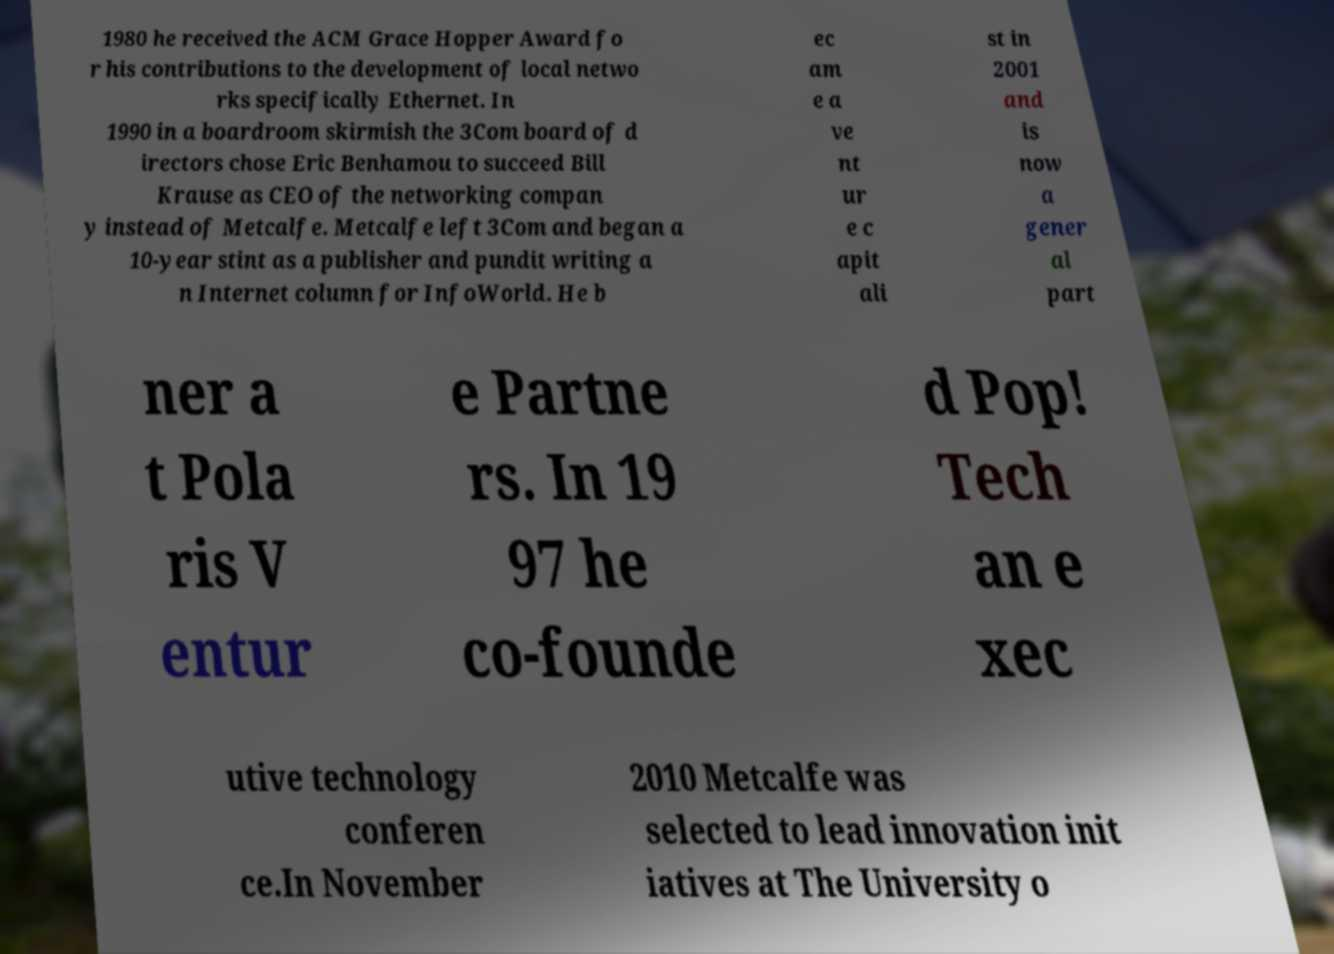What messages or text are displayed in this image? I need them in a readable, typed format. 1980 he received the ACM Grace Hopper Award fo r his contributions to the development of local netwo rks specifically Ethernet. In 1990 in a boardroom skirmish the 3Com board of d irectors chose Eric Benhamou to succeed Bill Krause as CEO of the networking compan y instead of Metcalfe. Metcalfe left 3Com and began a 10-year stint as a publisher and pundit writing a n Internet column for InfoWorld. He b ec am e a ve nt ur e c apit ali st in 2001 and is now a gener al part ner a t Pola ris V entur e Partne rs. In 19 97 he co-founde d Pop! Tech an e xec utive technology conferen ce.In November 2010 Metcalfe was selected to lead innovation init iatives at The University o 